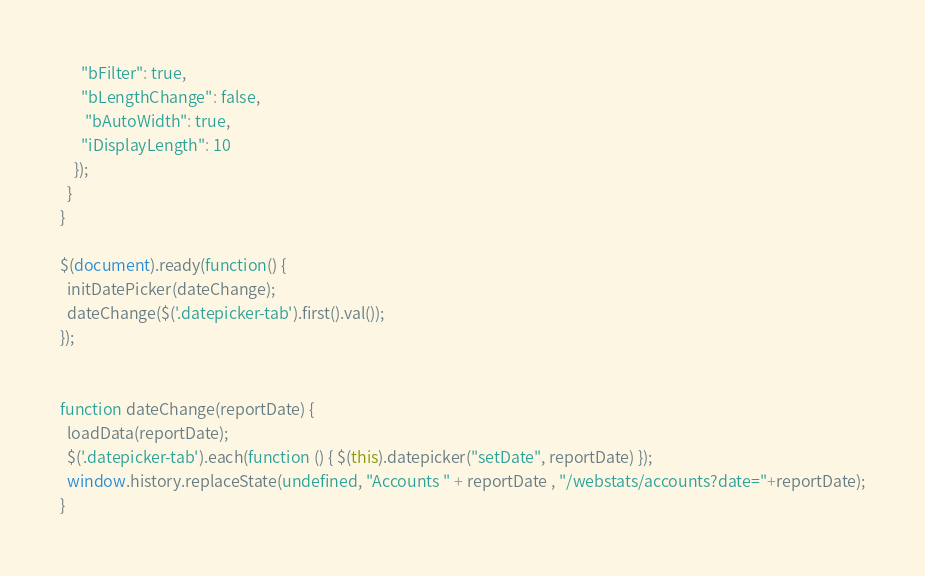Convert code to text. <code><loc_0><loc_0><loc_500><loc_500><_JavaScript_>      "bFilter": true,
      "bLengthChange": false,
       "bAutoWidth": true,
      "iDisplayLength": 10
    });
  }
}

$(document).ready(function() {
  initDatePicker(dateChange);
  dateChange($('.datepicker-tab').first().val());
});


function dateChange(reportDate) {
  loadData(reportDate);
  $('.datepicker-tab').each(function () { $(this).datepicker("setDate", reportDate) });
  window.history.replaceState(undefined, "Accounts " + reportDate , "/webstats/accounts?date="+reportDate);
}
</code> 